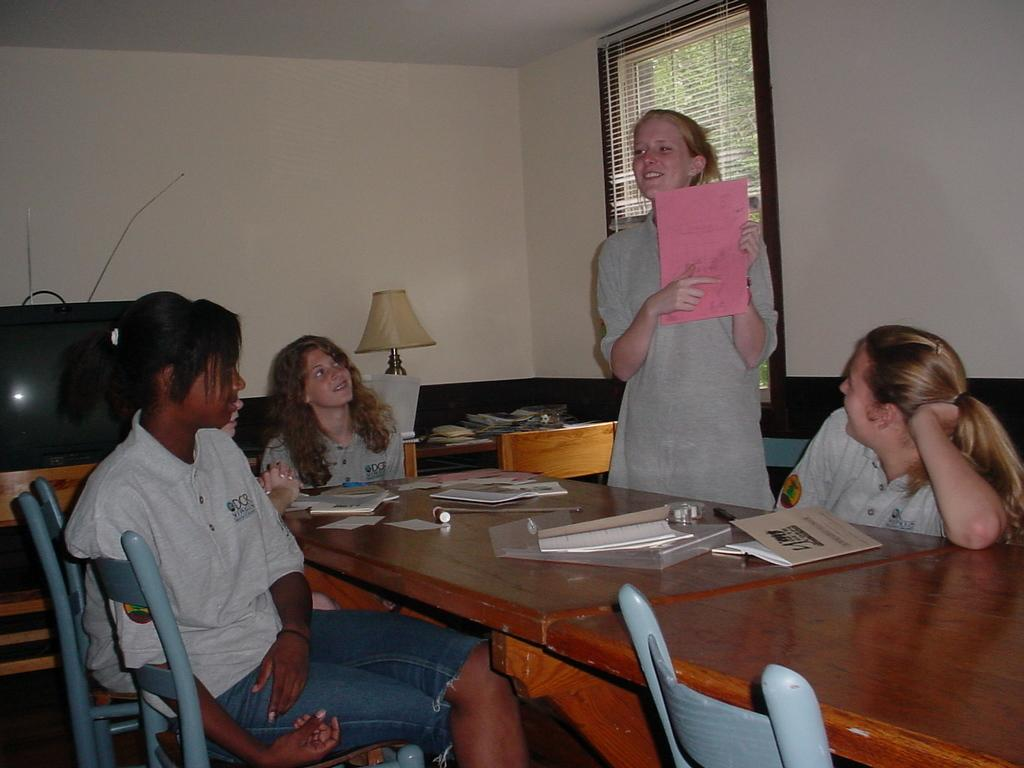What is the color of the wall in the image? The wall in the image is white. What can be seen on the wall in the image? There is a window on the wall in the image. What are the people in the image doing? The people in the image are sitting on chairs. What electronic device is present in the image? There is a television in the image. What piece of furniture is present in the image besides chairs? There is a table in the image. What type of cake is being served on the table in the image? There is no cake present in the image; it features a television and people sitting on chairs. What utensil is being used to stir the cake batter in the image? There is no cake batter or spoon present in the image. 